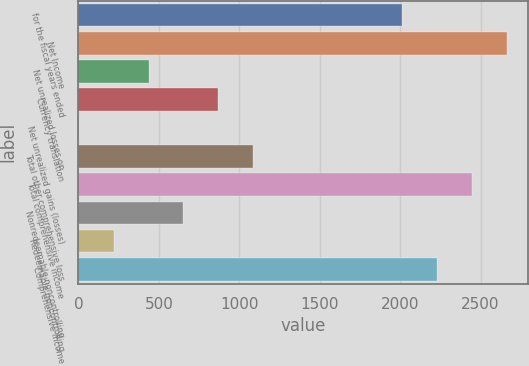<chart> <loc_0><loc_0><loc_500><loc_500><bar_chart><fcel>for the fiscal years ended<fcel>Net Income<fcel>Net unrealized losses on<fcel>Currency translation<fcel>Net unrealized gains (losses)<fcel>Total other comprehensive loss<fcel>Total comprehensive income<fcel>Nonredeemable noncontrolling<fcel>Redeemable noncontrolling<fcel>Comprehensive Income<nl><fcel>2013<fcel>2663.7<fcel>435.5<fcel>869.3<fcel>1.7<fcel>1086.2<fcel>2446.8<fcel>652.4<fcel>218.6<fcel>2229.9<nl></chart> 